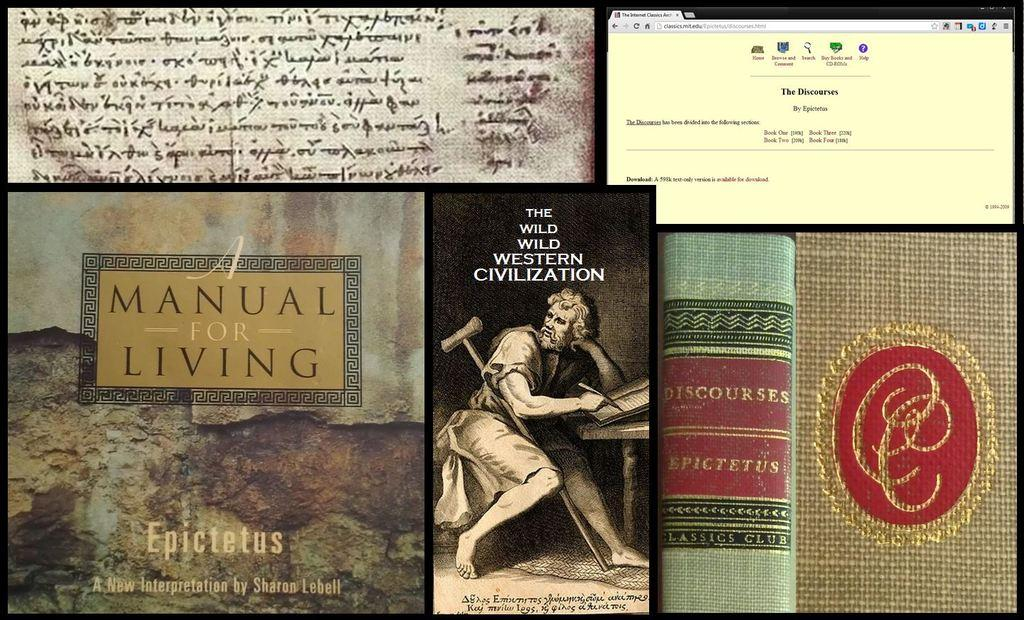Provide a one-sentence caption for the provided image. A collection of books about living a manual life. 